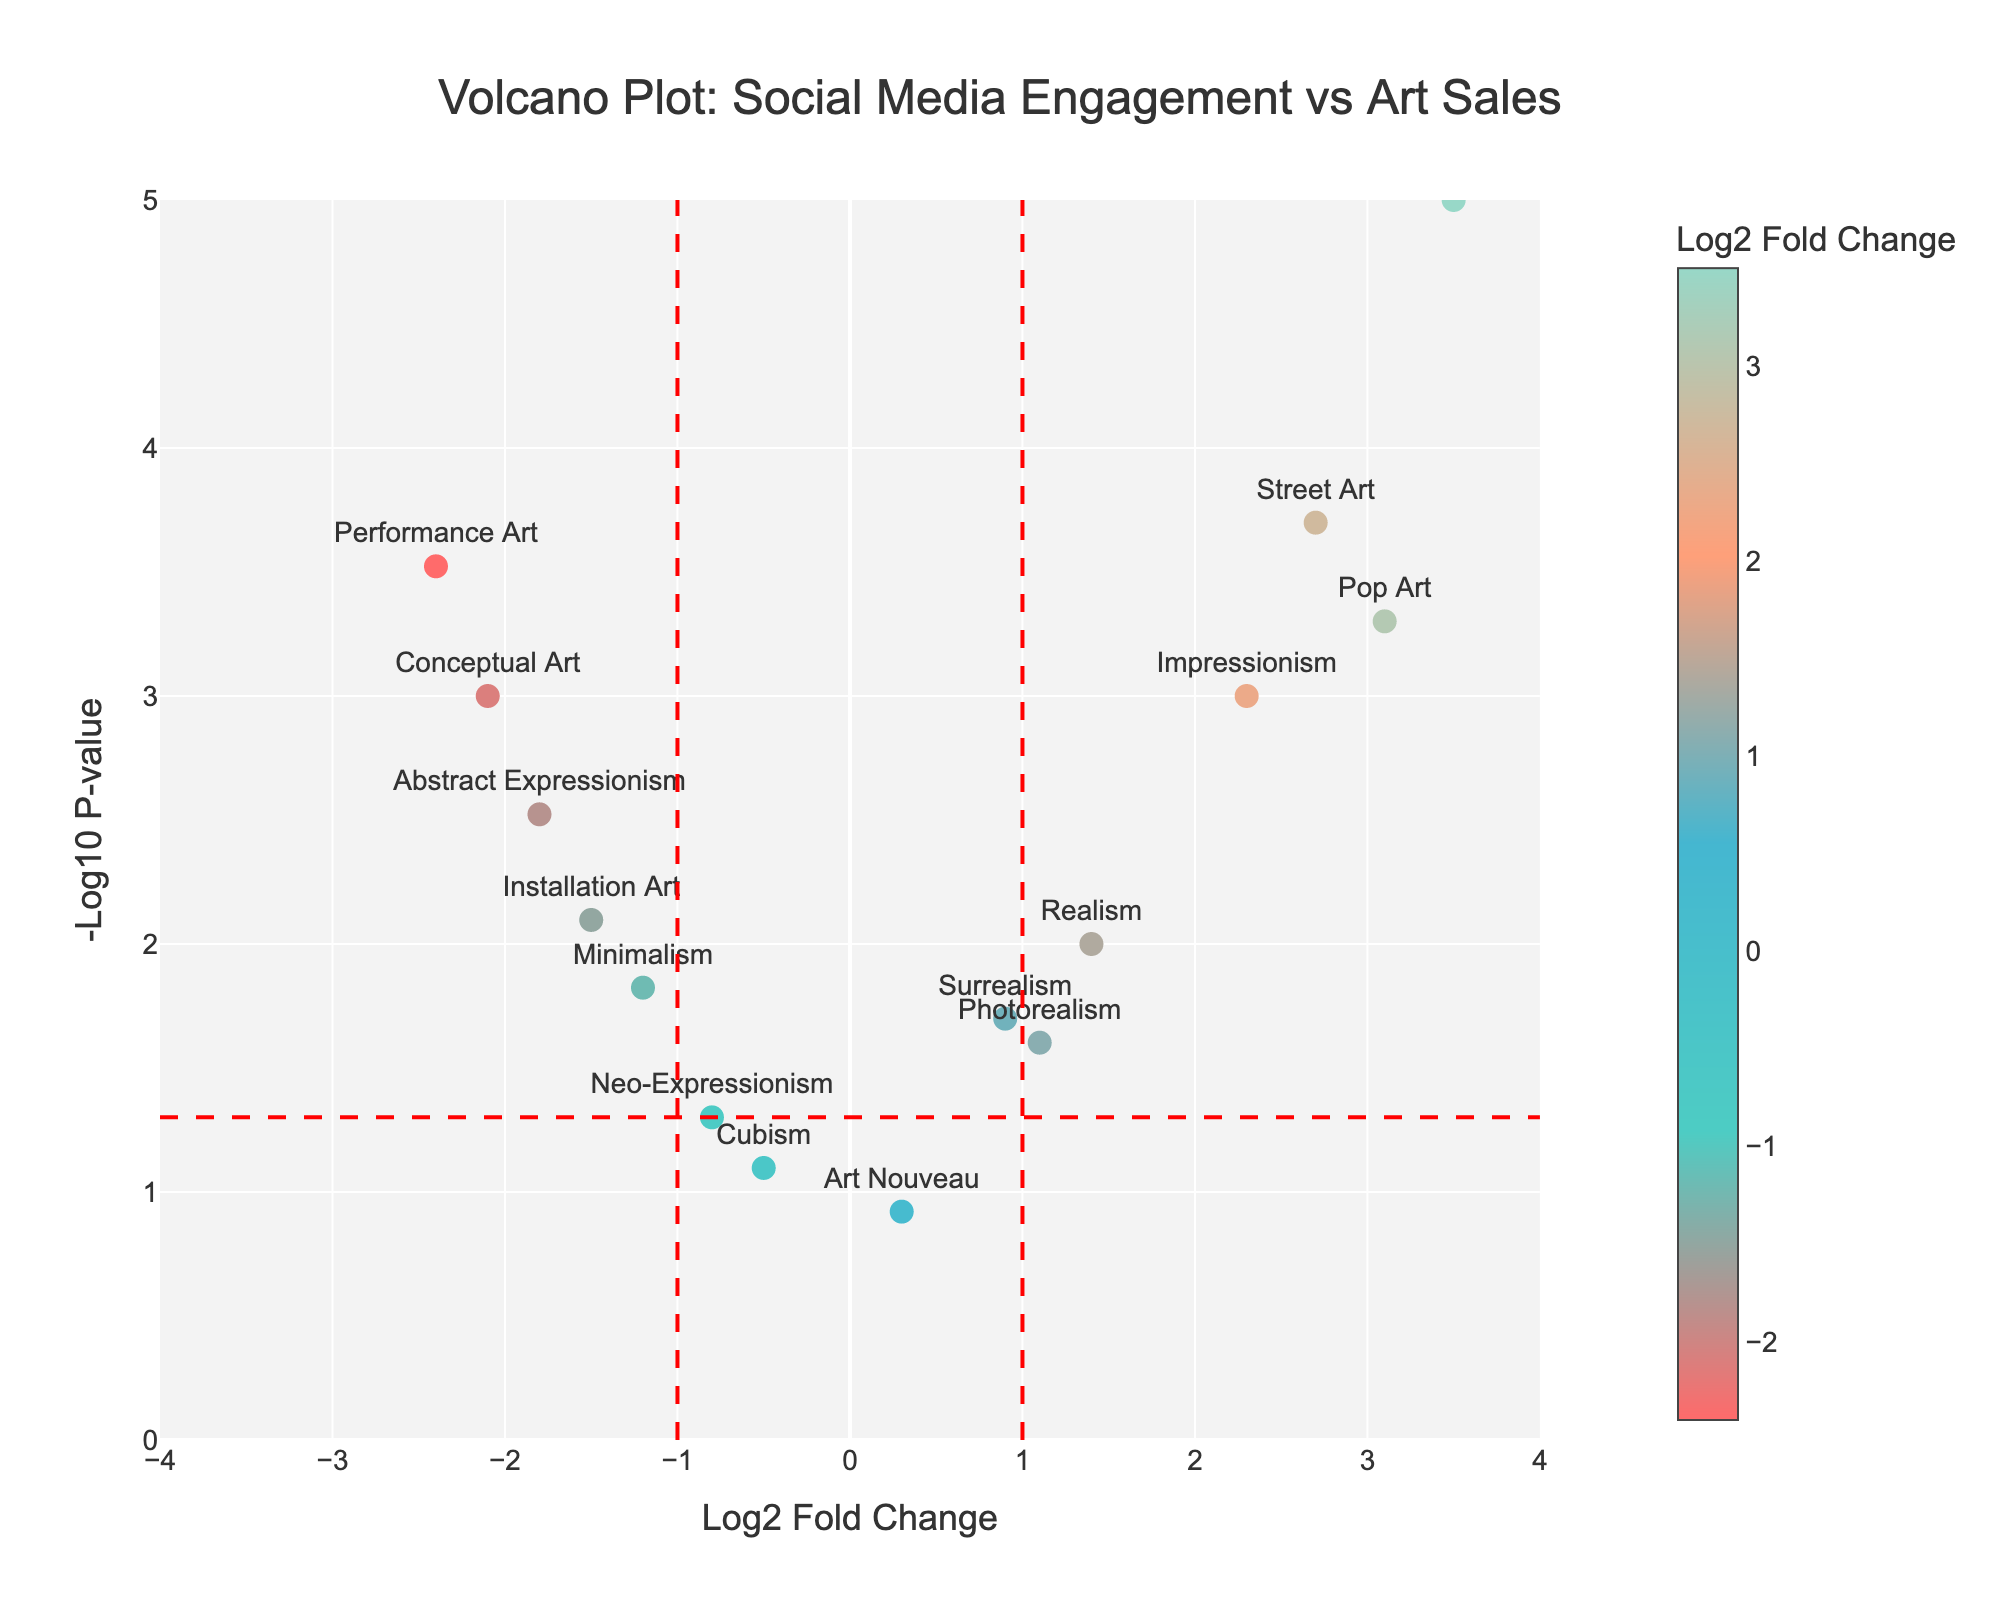What is the title of the plot? The title is usually displayed at the top of the plot. In this figure, it reads "Volcano Plot: Social Media Engagement vs Art Sales."
Answer: Volcano Plot: Social Media Engagement vs Art Sales What does the x-axis represent in the plot? The x-axis title provides information about what the axis represents. Here, the x-axis is labeled "Log2 Fold Change."
Answer: Log2 Fold Change Which artistic movement has the highest Log2 Fold Change? Locate the point with the highest x-axis value by observing where it lies farthest to the right. This point is labeled with "Digital Art," indicating it has the highest Log2 Fold Change.
Answer: Digital Art How many artistic movements have a p-value less than 0.05? Identify the points above the horizontal red dashed line, which signifies the p-value threshold of 0.05. Count the number of points above this line. There are 12 artistic movements that meet this criterion.
Answer: 12 Which movement shows the lowest log2 fold change along with a significant p-value (below 0.05)? Locate the point farthest to the left with a y-axis value above the horizontal red dashed line. This point represents "Performance Art."
Answer: Performance Art Which three movements have the most significant p-values? The most significant p-values correspond to the highest y-axis values (-log10(p)). Identify the top three points on the y-axis, which are "Digital Art," "Street Art," and "Pop Art."
Answer: Digital Art, Street Art, Pop Art What does a negative Log2 Fold Change indicate about an artistic movement's social media engagement and art sales correlation? A negative Log2 Fold Change, found to the left of the vertical dashed line at Log2 Fold Change = 0, indicates that less social media engagement correlates with lower art sales for that movement.
Answer: Lower sales with less engagement Compare the significance of Pop Art and Impressionism in terms of p-values. Observe the y-axis values of "Pop Art" (higher up on the plot) and "Impressionism." "Pop Art" has a more significant p-value since it appears higher on the y-axis.
Answer: Pop Art has more significant p-value Which movements have a log2 fold change close to zero but are still significant (p-value < 0.05)? Find points near the vertical dashed line at Log2 Fold Change = 0 and above the horizontal dashed line. "Surrealism" and "Realism" meet these criteria.
Answer: Surrealism, Realism What does the color scaling of points indicate, and which color represents the highest log2 fold change? The color scale maps the Log2 Fold Change values, where different colors indicate varying changes. The point with the highest Log2 Fold Change is "Digital Art," which corresponds to the color representing the highest change on the color scale.
Answer: Color indicates fold change, highest is for Digital Art 